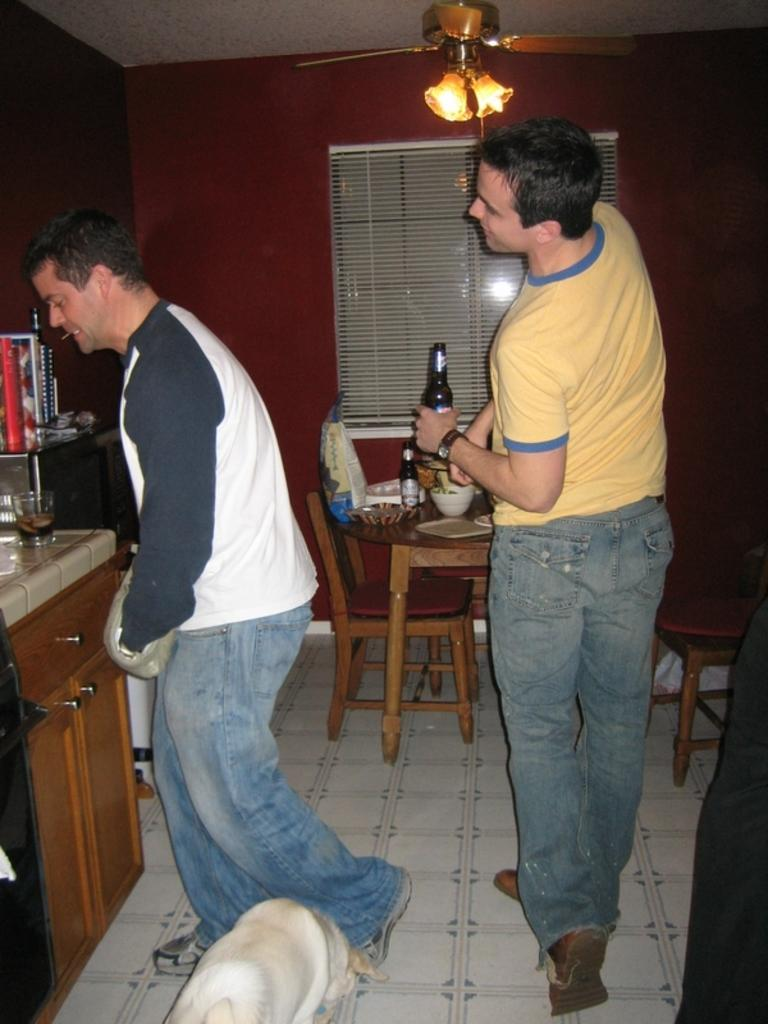What is the man standing at the table doing? The man standing at the table has a wine glass on the table. What is the other man in the image doing? The other man is walking. What is the walking man holding in his hand? The walking man has a beer bottle in his hand. What is the price of the wine glass in the image? The provided facts do not mention the price of the wine glass, so it cannot be determined from the image. 